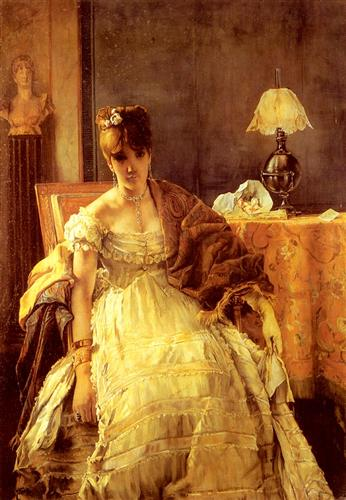Can you tell me more about the era in which this painting might have been created? This painting seems to hail from the late 19th to early 20th century, a period known for its detailed and realistic portrayal in art. This era was characterized by a transition from the Romanticism of the early 19th century to the more grounded, everyday scenes of Realism and eventually to the Symbolism and Impressionism movements. The woman's attire, with its elegant yet intricate design, mirrors the fashion trends of that time, which valued opulence and detail. The furniture and decor also reflect the time's penchant for luxurious yet tasteful domestic interiors. How might this image reflect social or cultural aspects of its time? This painting can be seen as a window into the societal norms and aspirations of its era. The woman's attire and accessories suggest her high social standing, indicative of a class that valued education, refinement, and leisure. The setting, complete with fine furniture and décor, reflects the domestic ideal of comfort and elegance that was aspired to during that period. The painting also captures the introspective nature of the subject, a theme often explored in portraits of women during this time, which could hint at the evolving roles and self-awareness of women in society. This portrayal combines personal identity with a reflection of broader social constructs, making it a rich subject for exploring historical and cultural contexts. 